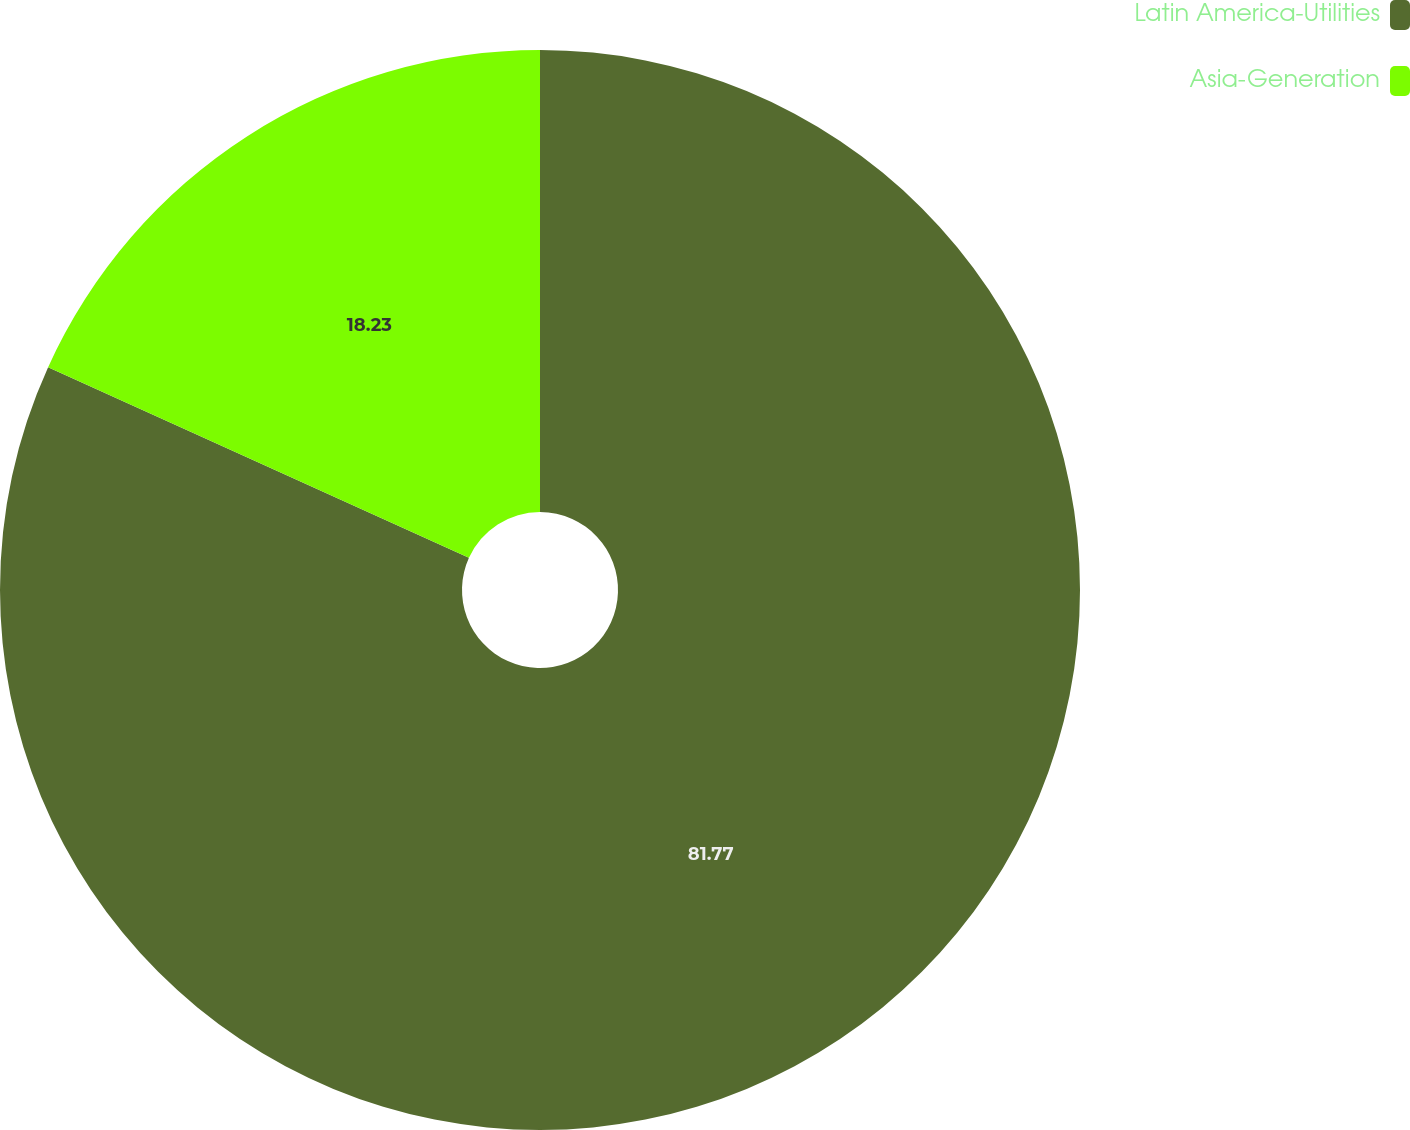Convert chart. <chart><loc_0><loc_0><loc_500><loc_500><pie_chart><fcel>Latin America-Utilities<fcel>Asia-Generation<nl><fcel>81.77%<fcel>18.23%<nl></chart> 